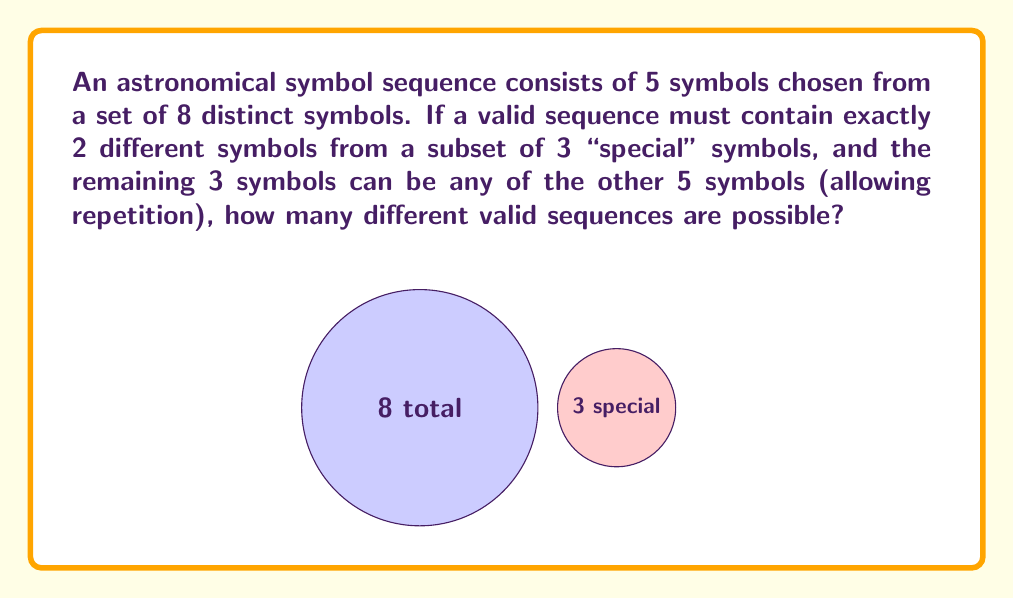Can you solve this math problem? Let's break this down step-by-step:

1) First, we need to choose 2 special symbols from the 3 available. This can be done in $\binom{3}{2} = 3$ ways.

2) We need to decide where to place these 2 special symbols in the sequence of 5. This can be done in $\binom{5}{2} = 10$ ways.

3) For the remaining 3 positions, we can use any of the 5 non-special symbols, and repetition is allowed. This is a case of choosing with replacement, so we have 5 choices for each of the 3 positions. This gives us $5^3 = 125$ possibilities.

4) By the multiplication principle, the total number of valid sequences is:

   $$ 3 \times 10 \times 125 = 3750 $$

Therefore, there are 3750 different valid sequences possible.
Answer: 3750 